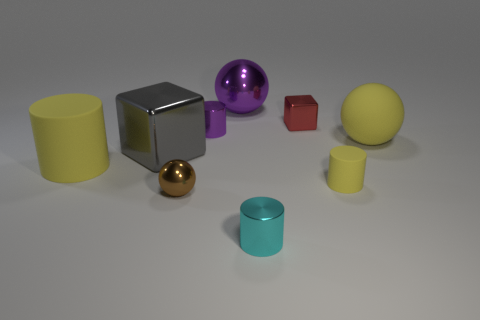What number of blocks are big gray objects or tiny yellow objects?
Provide a short and direct response. 1. What is the size of the purple sphere that is made of the same material as the gray thing?
Offer a terse response. Large. How many small objects have the same color as the tiny sphere?
Provide a succinct answer. 0. Are there any large yellow balls to the right of the small ball?
Make the answer very short. Yes. There is a brown thing; is it the same shape as the purple object behind the red metallic block?
Provide a short and direct response. Yes. How many things are big spheres left of the small yellow matte thing or yellow things?
Make the answer very short. 4. What number of metal blocks are both in front of the tiny red metal cube and behind the purple cylinder?
Your answer should be compact. 0. How many things are large yellow matte objects in front of the yellow matte ball or spheres that are behind the large gray block?
Your answer should be compact. 3. What number of other things are the same shape as the small brown thing?
Your answer should be compact. 2. There is a small cylinder on the right side of the tiny cyan metallic object; is its color the same as the big cylinder?
Your answer should be compact. Yes. 